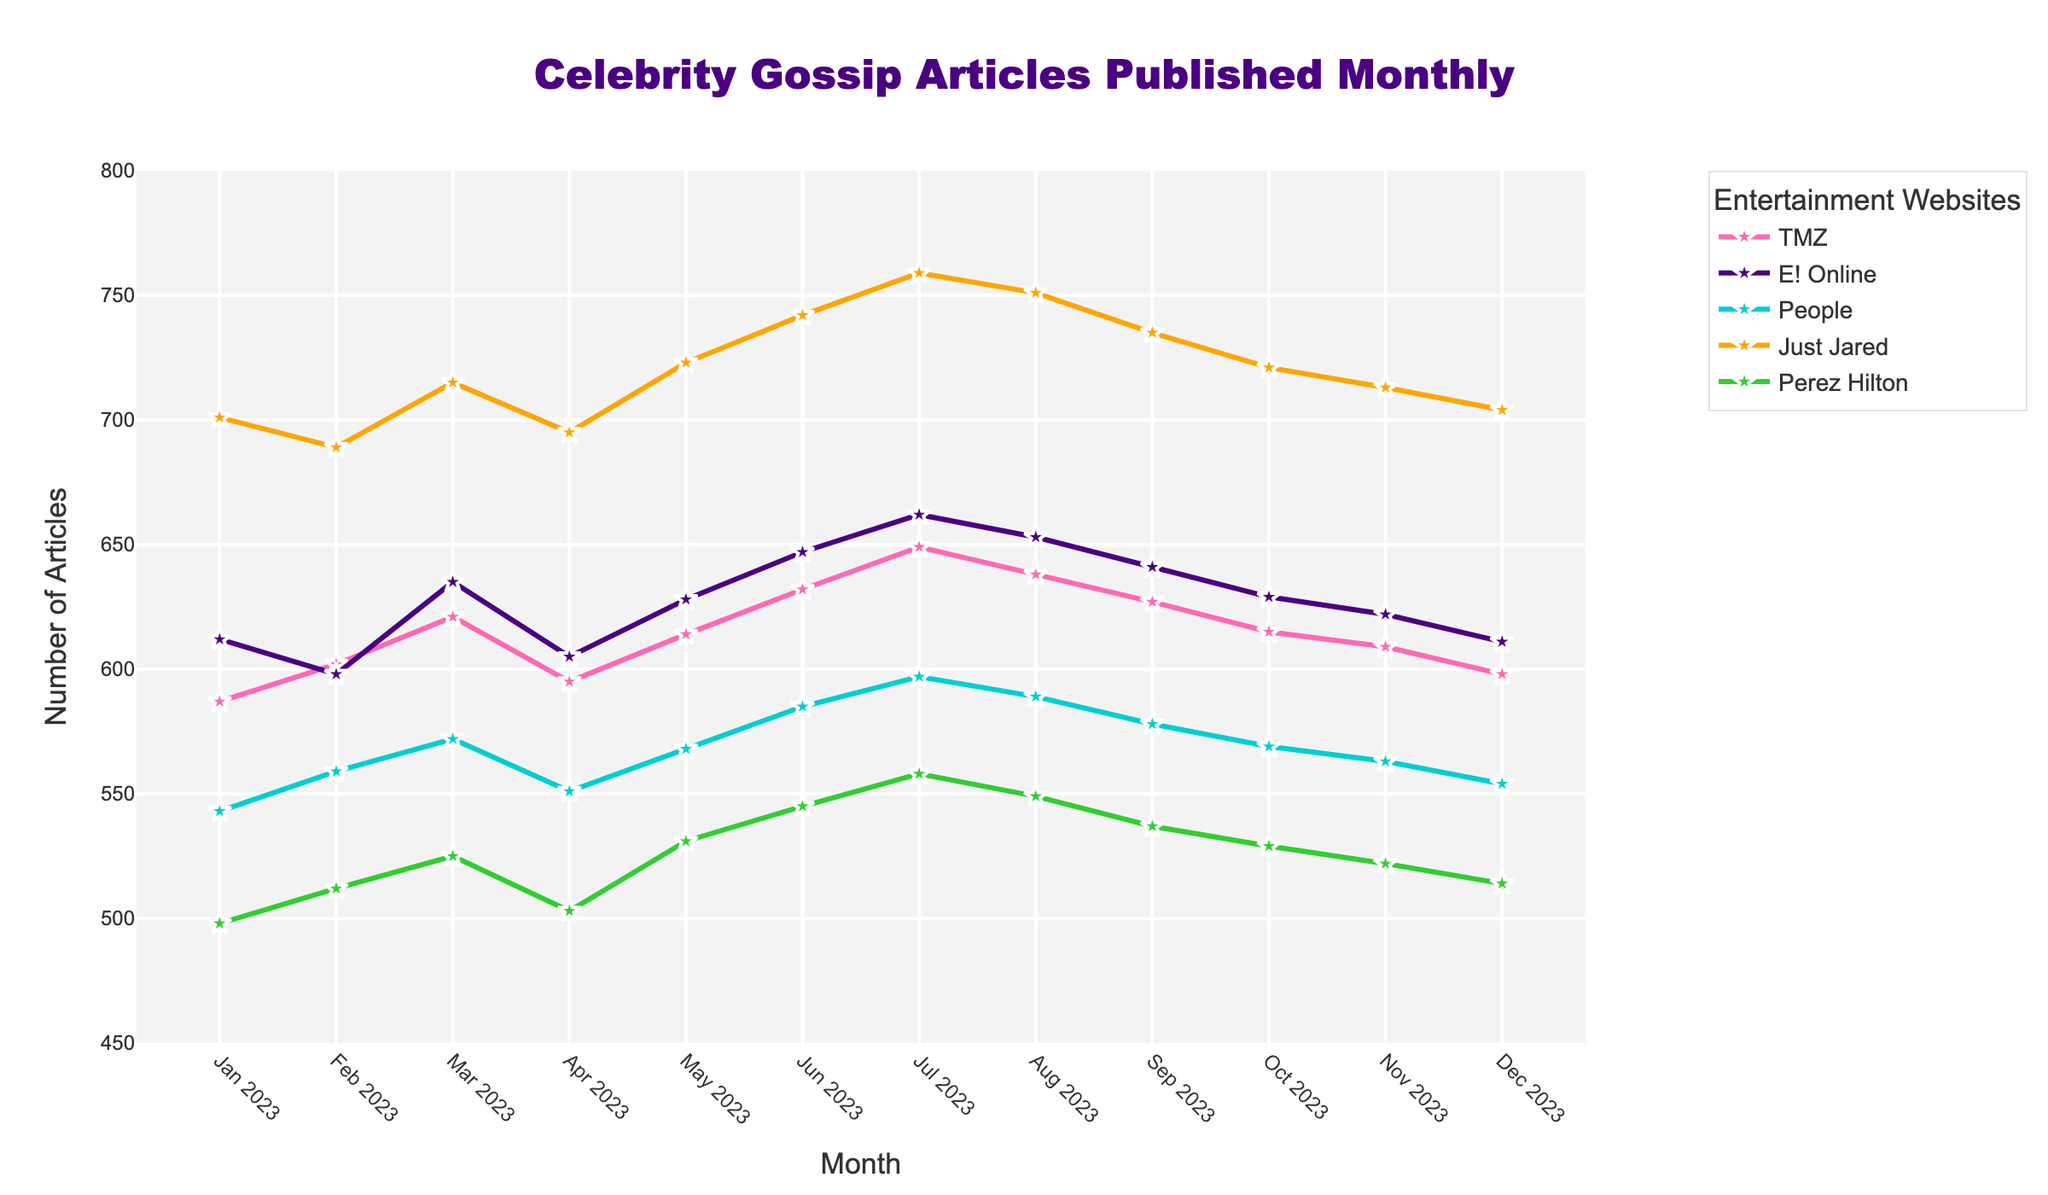What is the average number of articles published by TMZ from January to December 2023? To find the average, sum all monthly values for TMZ and divide by 12. Summing the numbers: 587 + 602 + 621 + 595 + 614 + 632 + 649 + 638 + 627 + 615 + 609 + 598 = 7387. Now divide by 12: 7387/12 = 615.58
Answer: 615.58 Which website had the highest number of articles published in March 2023? In March 2023, the number of articles for each website are: TMZ - 621, E! Online - 635, People - 572, Just Jared - 715, Perez Hilton - 525. The highest value is 715 by Just Jared.
Answer: Just Jared What was the difference in the number of articles published by People and Perez Hilton in July 2023? In July 2023, People published 597 articles and Perez Hilton published 558 articles. The difference is 597 - 558 = 39.
Answer: 39 Which month had the lowest number of articles published by E! Online? E! Online's numbers each month are: 612, 598, 635, 605, 628, 647, 662, 653, 641, 629, 622, 611. The lowest value is 598 in February 2023.
Answer: February 2023 Compare the number of articles published by Just Jared in June 2023 to December 2023. Is it higher, lower, or equal? Just Jared published 742 articles in June 2023 and 704 articles in December 2023. 742 is greater than 704, so the number is higher in June.
Answer: Higher What is the trend observed for TMZ from January to December 2023? Plotting the values for TMZ: 587, 602, 621, 595, 614, 632, 649, 638, 627, 615, 609, 598, we see the general trend is upward initially until July, followed by a slight decline towards December.
Answer: Upward then slight decline If we sum the articles published by Perez Hilton in the first quarter of 2023, what is the total? Summing Perez Hilton's articles for January, February, and March 2023: 498 + 512 + 525 = 1535.
Answer: 1535 How many more articles did Just Jared publish in August compared to October 2023? Just Jared published 751 articles in August and 721 articles in October. The difference is 751 - 721 = 30.
Answer: 30 Which website consistently published more than 600 articles each month? Checking the values for each website: Just Jared consistently published more than 600 each month (701, 689, 715, 695, 723, 742, 759, 751, 735, 721, 713, 704).
Answer: Just Jared 